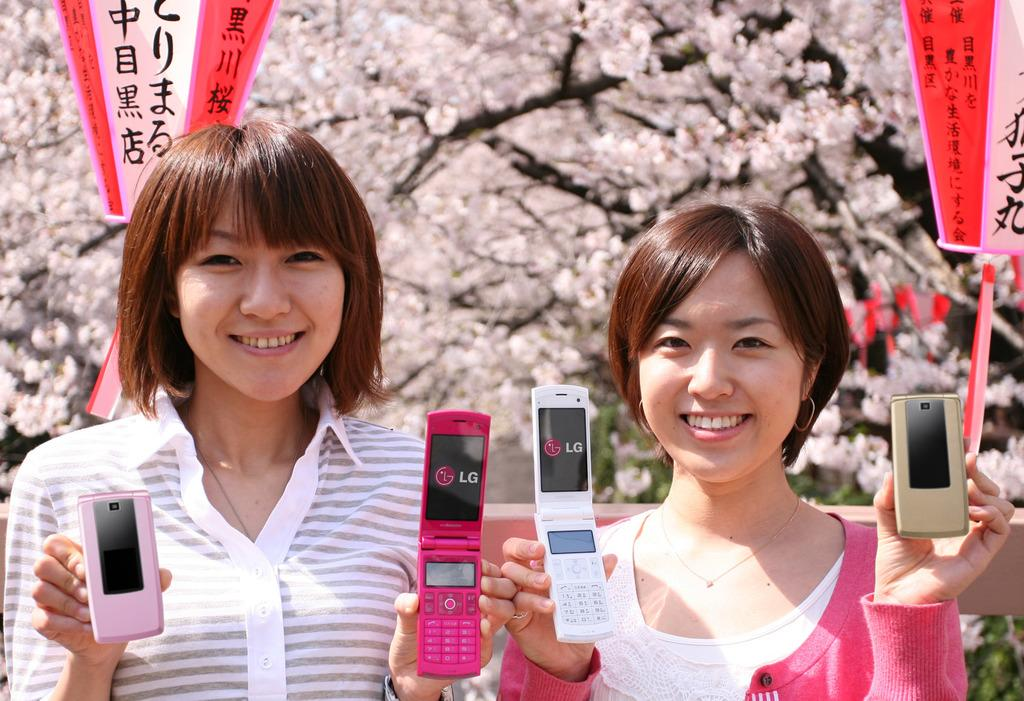How many women are in the image? There are two women in the image. What are the women holding in their hands? The women are holding mobiles in each hand. What is the facial expression of the women? The women are smiling. What can be seen in the background of the image? There are banners and trees in the background of the image. What type of fruit can be seen bursting in the image? There is no fruit present in the image, let alone one that is bursting. 